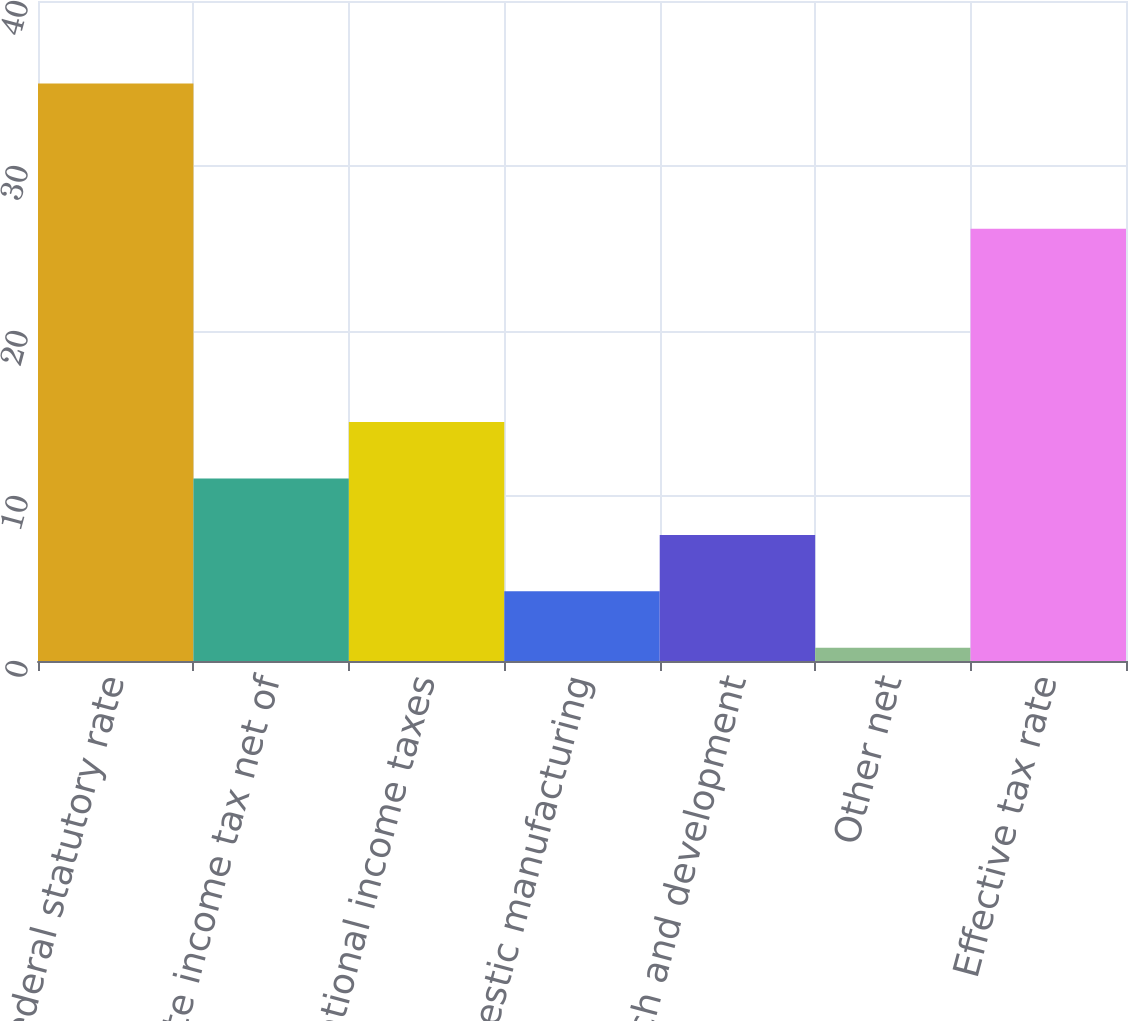Convert chart to OTSL. <chart><loc_0><loc_0><loc_500><loc_500><bar_chart><fcel>US federal statutory rate<fcel>State income tax net of<fcel>International income taxes<fcel>Domestic manufacturing<fcel>Research and development<fcel>Other net<fcel>Effective tax rate<nl><fcel>35<fcel>11.06<fcel>14.48<fcel>4.22<fcel>7.64<fcel>0.8<fcel>26.2<nl></chart> 